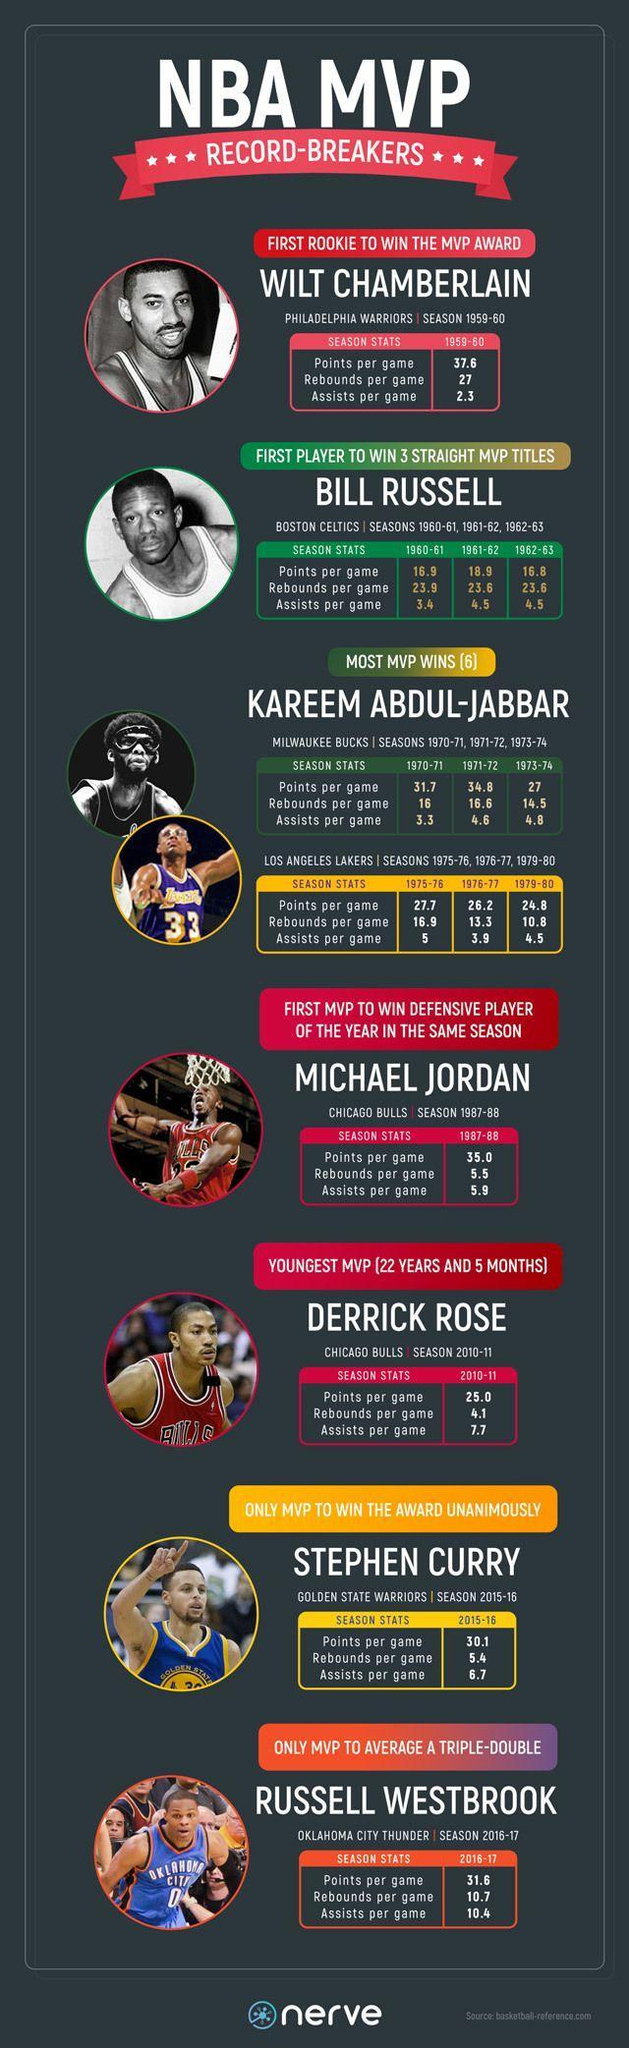How many rebounds per game for Bill Russell in 1961-62
Answer the question with a short phrase. 23.6 What is the colour of the T Shirt for Derrick Rose, red or blue red How many rebounds per game for Kareem Abdul Jabbar in 1973-74 14.5 Which players from Chicago Bulls Michael Jordan, Derrick Rose Which teams has Kareem Abdul-Jabbar played in Milwaukee Bucks, Los Angeles Lakers How many seasons has Bill Russell played 3 